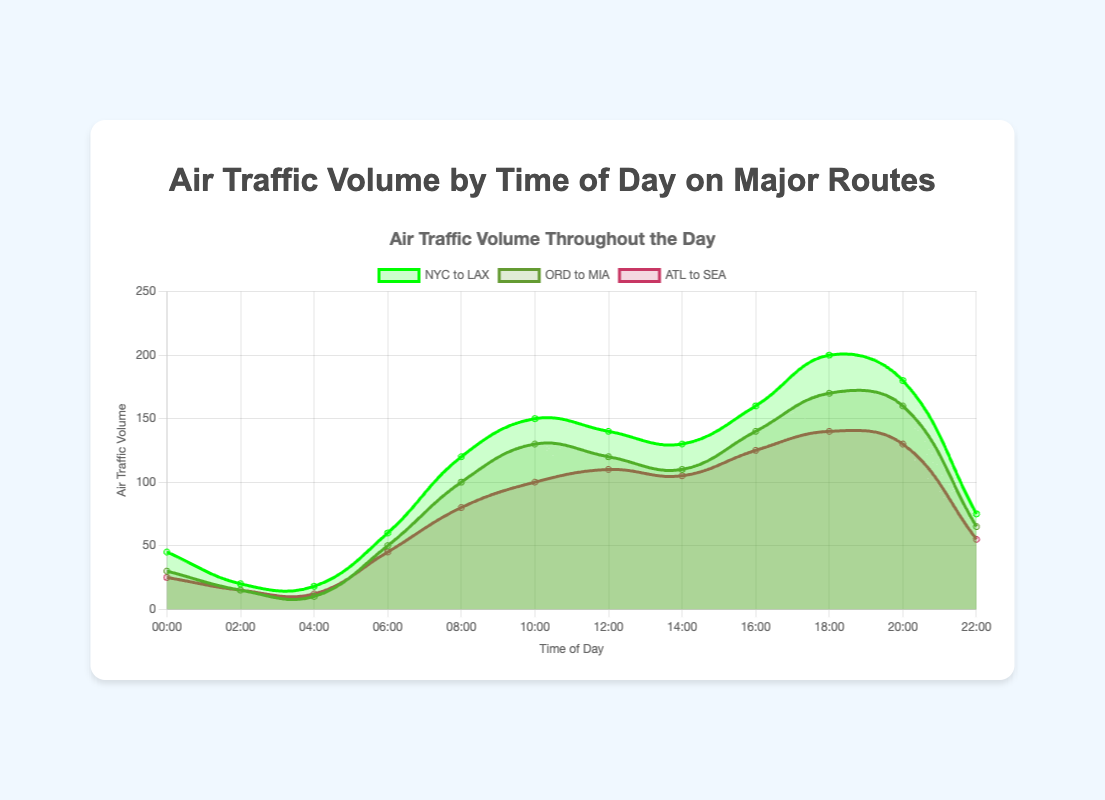What's the title of the chart? The title of the chart is centrally positioned at the top and reads "Air Traffic Volume Throughout the Day."
Answer: Air Traffic Volume Throughout the Day What does the x-axis represent? The x-axis of the chart is labeled "Time of Day" and represents different times from 00:00 to 22:00 in 2-hour intervals.
Answer: Time of Day Which route has the highest air traffic volume at 18:00? At 18:00, the volume for each route is: NYC to LAX (200), ORD to MIA (170), and ATL to SEA (140). The highest is NYC to LAX with 200.
Answer: NYC to LAX What time of day does the NYC to LAX route have its peak volume? By observing the peaks in the area chart lines, the NYC to LAX route clearly reaches its highest volume at 18:00 with 200.
Answer: 18:00 Compare the air traffic volumes of all routes at 10:00. Which route has the most volume? At 10:00, the volumes are: NYC to LAX (150), ORD to MIA (130), and ATL to SEA (100). NYC to LAX has the most volume with 150.
Answer: NYC to LAX What is the average air traffic volume for the ORD to MIA route throughout the day? To find the average, add all the volumes for ORD to MIA (30 + 15 + 10 + 50 + 100 + 130 + 120 + 110 + 140 + 170 + 160 + 65 = 1100) and divide by the number of points (12). 1100 / 12 = approx. 91.67.
Answer: 91.67 Which route has the smallest range in air traffic volume over the day? The range is calculated as max volume minus min volume for each route. ORD to MIA: 170 – 10 = 160, NYC to LAX: 200 – 18 = 182, ATL to SEA: 140 – 12 = 128. The smallest range is for ATL to SEA with 128.
Answer: ATL to SEA At what time does the ATL to SEA route start to significantly increase in volume? The chart shows an increase starting around 06:00, where the volume increases from 45 to 80 and continues to rise.
Answer: 06:00 How does the volume trend for the NYC to LAX route between 10:00 and 20:00 compare to that of the ATL to SEA route? Between 10:00 and 20:00, NYC to LAX peaks at 150 and continues to increase until 18:00, then slightly drops to 180 by 20:00. ATL to SEA starts at 100, peaks at 140, then drops to 130 by 20:00. NYC to LAX consistently has higher volumes and a sharper increase.
Answer: NYC to LAX has higher and sharper increase 